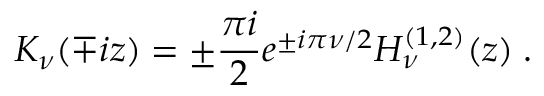<formula> <loc_0><loc_0><loc_500><loc_500>K _ { \nu } ( \mp i z ) = \pm \frac { \pi i } { 2 } e ^ { \pm i \pi \nu / 2 } H _ { \nu } ^ { ( 1 , 2 ) } ( z ) \, .</formula> 